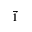<formula> <loc_0><loc_0><loc_500><loc_500>\vec { 1 }</formula> 